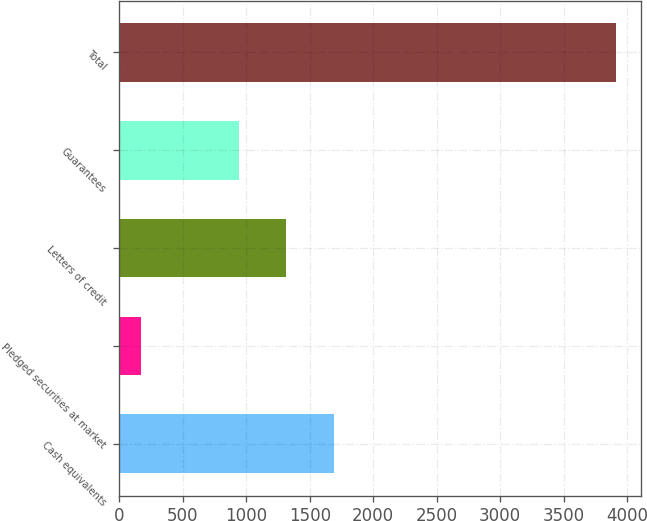Convert chart. <chart><loc_0><loc_0><loc_500><loc_500><bar_chart><fcel>Cash equivalents<fcel>Pledged securities at market<fcel>Letters of credit<fcel>Guarantees<fcel>Total<nl><fcel>1690.7<fcel>167<fcel>1316<fcel>941<fcel>3914<nl></chart> 